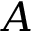Convert formula to latex. <formula><loc_0><loc_0><loc_500><loc_500>A</formula> 